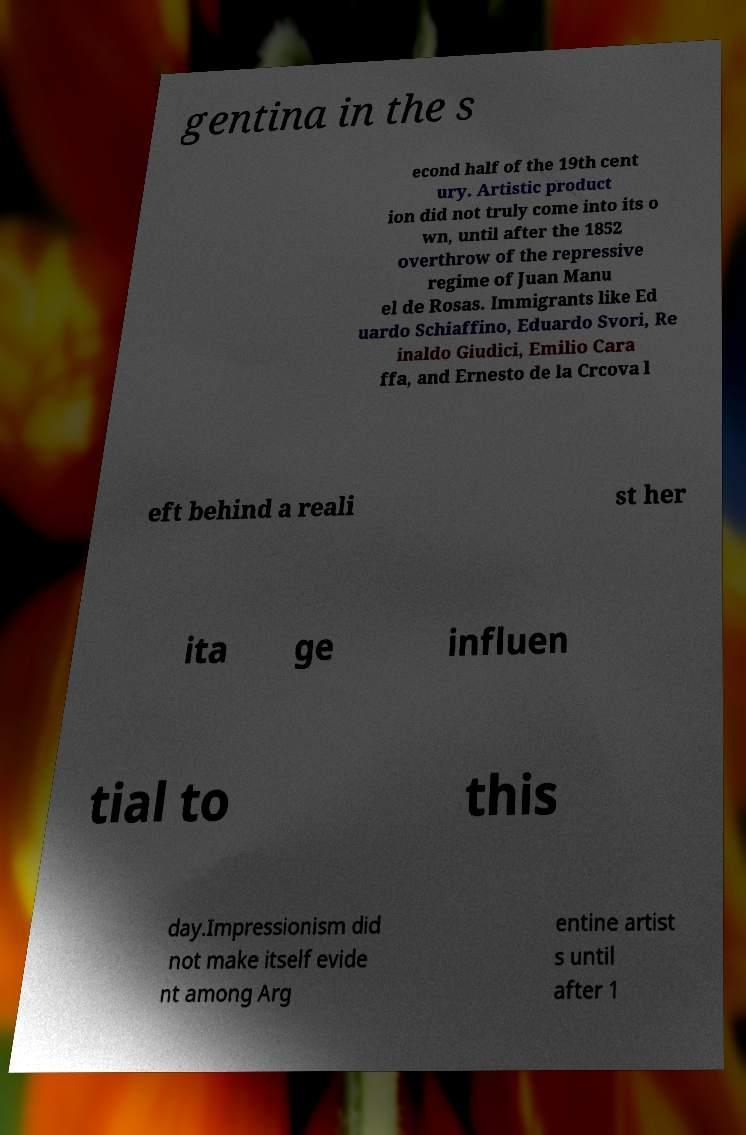Can you accurately transcribe the text from the provided image for me? gentina in the s econd half of the 19th cent ury. Artistic product ion did not truly come into its o wn, until after the 1852 overthrow of the repressive regime of Juan Manu el de Rosas. Immigrants like Ed uardo Schiaffino, Eduardo Svori, Re inaldo Giudici, Emilio Cara ffa, and Ernesto de la Crcova l eft behind a reali st her ita ge influen tial to this day.Impressionism did not make itself evide nt among Arg entine artist s until after 1 